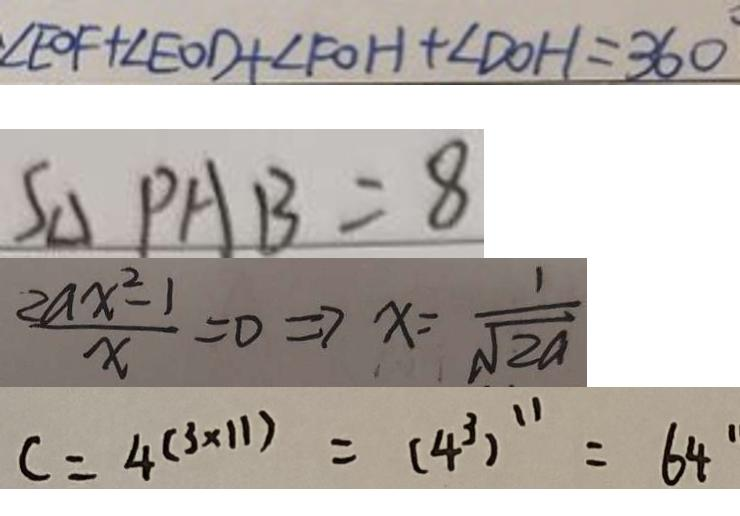<formula> <loc_0><loc_0><loc_500><loc_500>\angle E O F + \angle E O D + \angle F O H + \angle D O H = 3 6 0 
 S _ { \Delta } P A B = 8 
 \frac { 2 a x ^ { 2 } - 1 } { x } = 0 \Rightarrow x = \frac { 1 } { \sqrt { 2 a } } 
 c = 4 ^ { ( 3 \times 1 1 ) } = ( 4 ^ { 3 } ) ^ { 1 1 } = 6 4 ^ { \prime }</formula> 